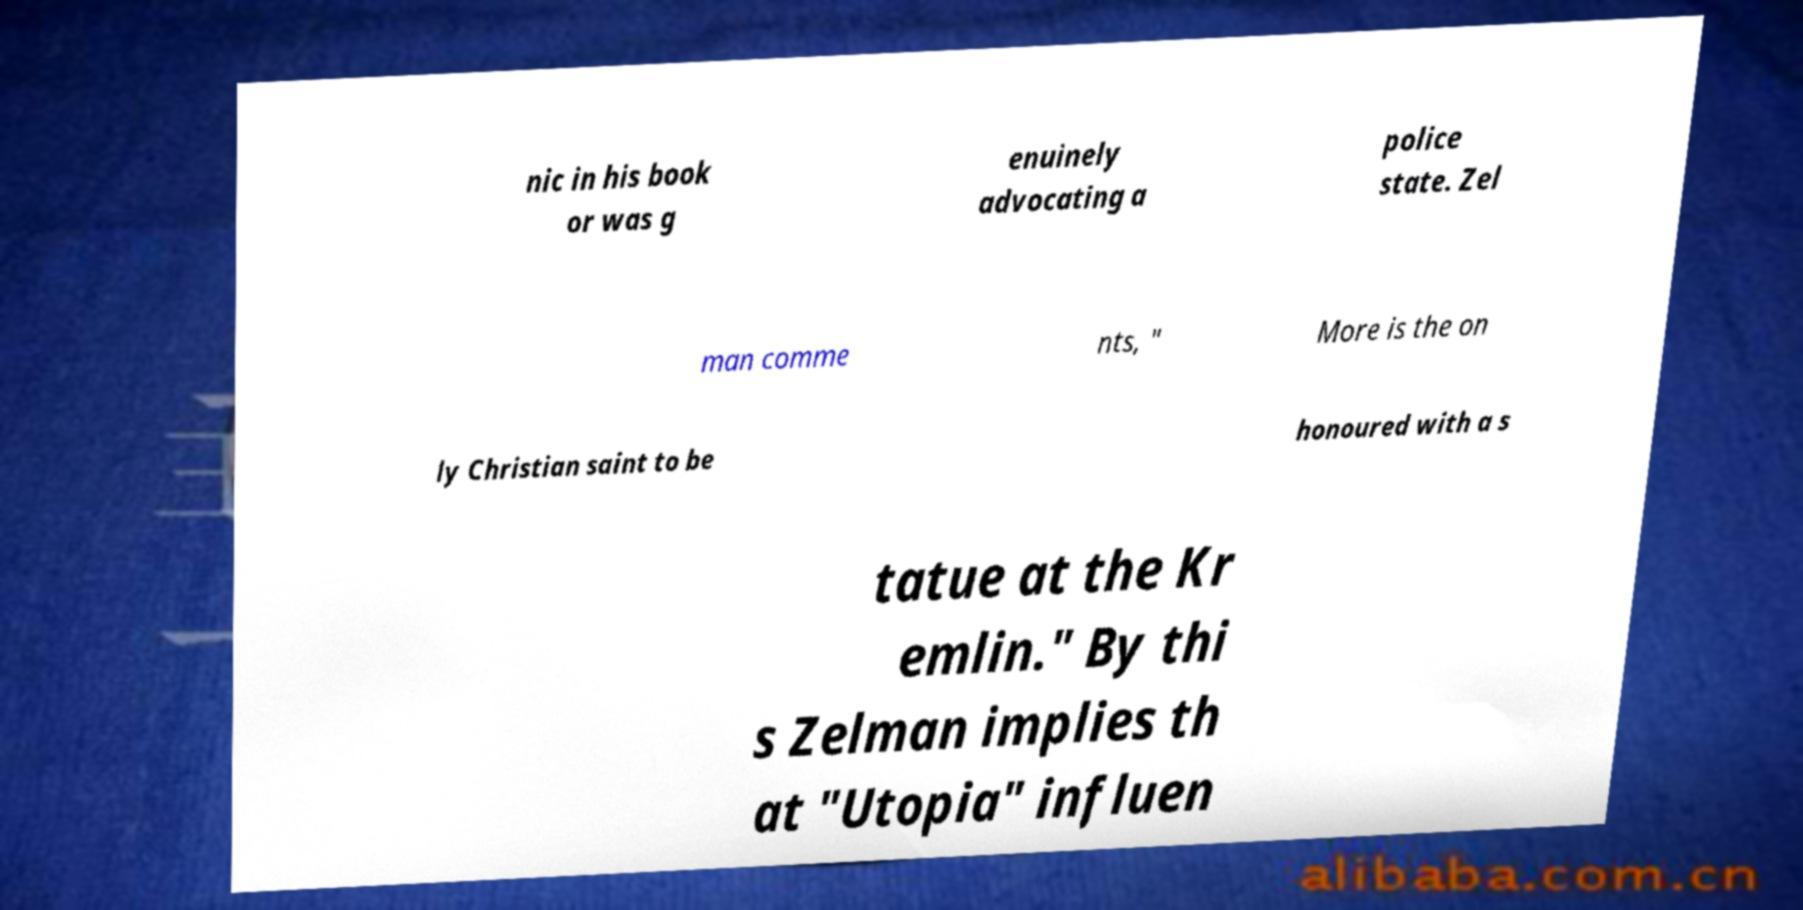What messages or text are displayed in this image? I need them in a readable, typed format. nic in his book or was g enuinely advocating a police state. Zel man comme nts, " More is the on ly Christian saint to be honoured with a s tatue at the Kr emlin." By thi s Zelman implies th at "Utopia" influen 